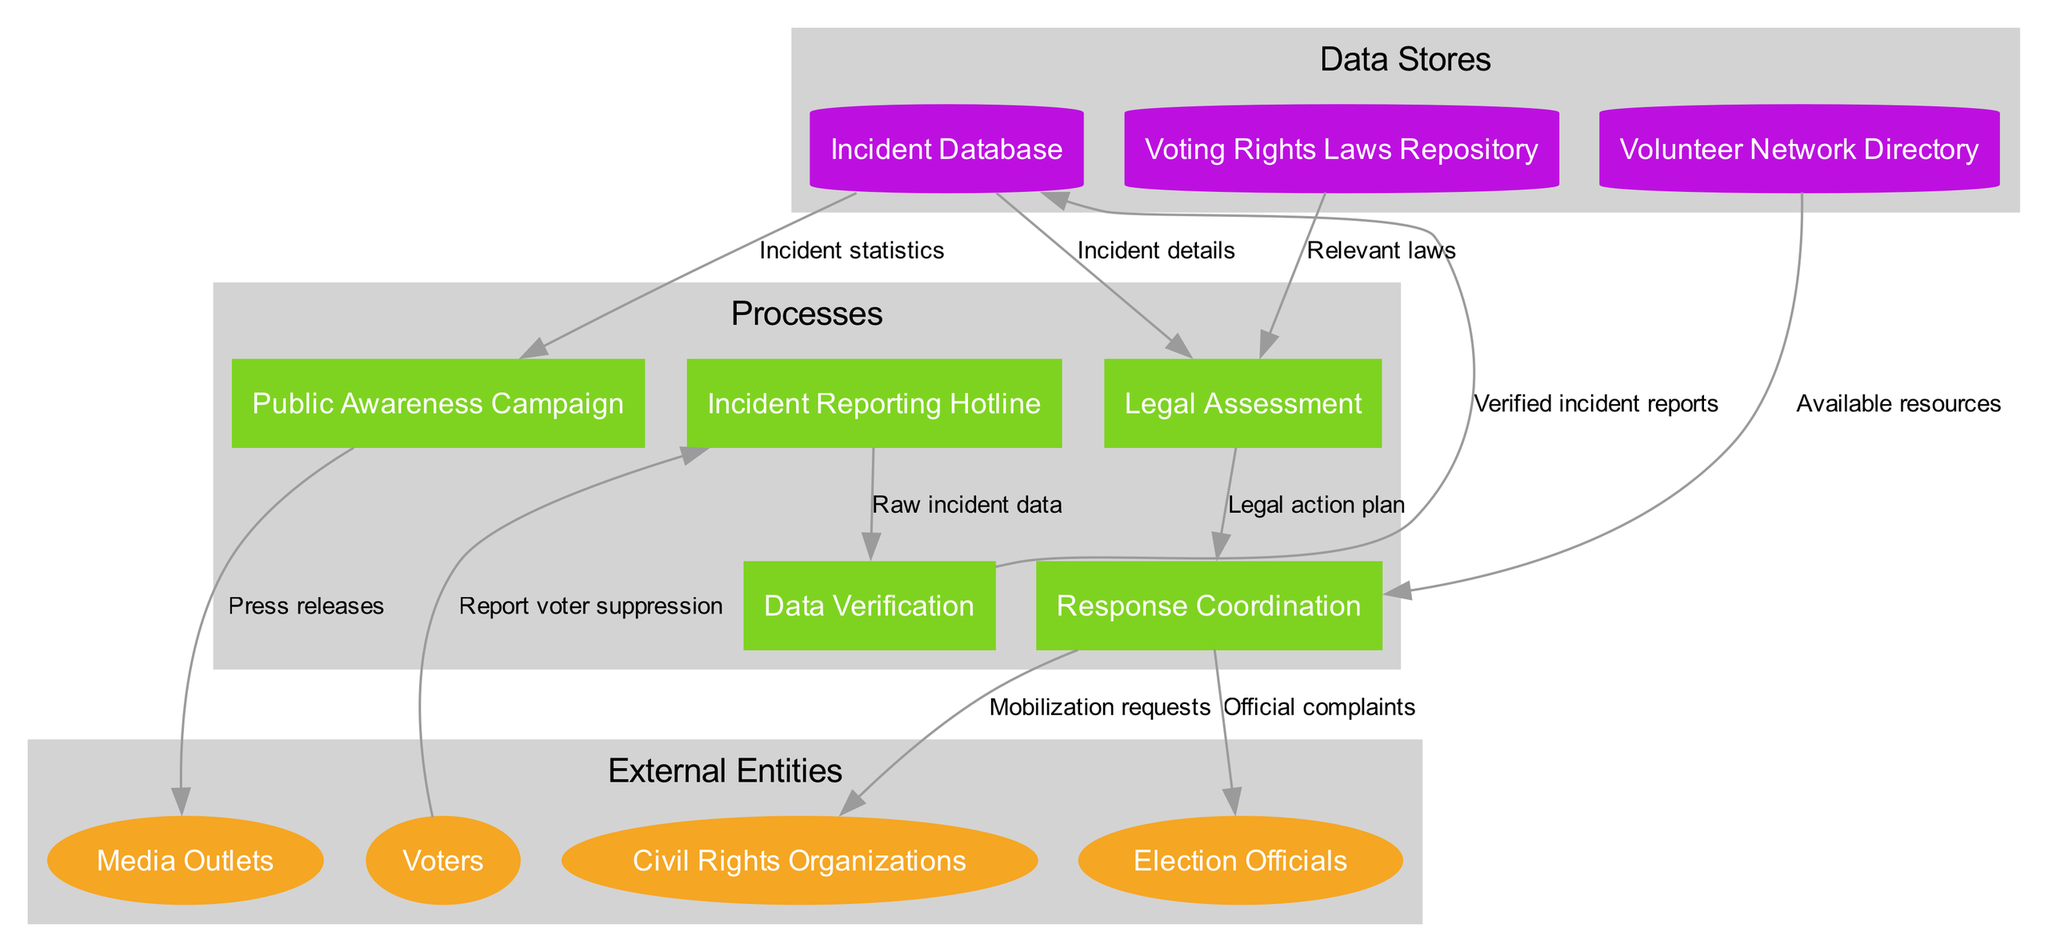What are the external entities in this diagram? The external entities are listed in the "External Entities" section of the diagram. They include "Voters," "Civil Rights Organizations," "Election Officials," and "Media Outlets."
Answer: Voters, Civil Rights Organizations, Election Officials, Media Outlets How many processes are shown in the diagram? The number of processes is displayed in the "Processes" section, which lists five distinct processes: "Incident Reporting Hotline," "Data Verification," "Legal Assessment," "Response Coordination," and "Public Awareness Campaign."
Answer: 5 What is the purpose of the Incident Reporting Hotline? The Incident Reporting Hotline is used by voters to report incidents of voter suppression, as indicated by the flow labeled "Report voter suppression" that moves from "Voters" to "Incident Reporting Hotline."
Answer: Report voter suppression What kind of data flow is sent from the Incident Database to the Legal Assessment process? The flow from the Incident Database to the Legal Assessment process sends "Incident details," which indicates the specific information collected about each reported incident for legal analysis.
Answer: Incident details Which entities receive mobilization requests from the Response Coordination process? The Response Coordination process sends mobilization requests to "Civil Rights Organizations," as indicated by the data flow labeled "Mobilization requests" that leads to this external entity.
Answer: Civil Rights Organizations What data is the Public Awareness Campaign using from the Incident Database? The Public Awareness Campaign utilizes "Incident statistics" from the Incident Database, as shown by the data flow connecting these two processes.
Answer: Incident statistics What is the relationship between the Legal Assessment and the Voting Rights Laws Repository? The Legal Assessment process requires "Relevant laws" from the Voting Rights Laws Repository, signifying that it assesses incidents based on legal frameworks provided in this data store.
Answer: Relevant laws Which process coordinates responses to voter suppression incidents? The process identified as "Response Coordination" is responsible for coordinating responses to the incidents, as indicated by the flows that lead to both Civil Rights Organizations and Election Officials.
Answer: Response Coordination How many data stores are depicted in the diagram? There are three data stores mentioned in the "Data Stores" section: "Incident Database," "Voting Rights Laws Repository," and "Volunteer Network Directory," indicating a count of three data stores used for managing information.
Answer: 3 